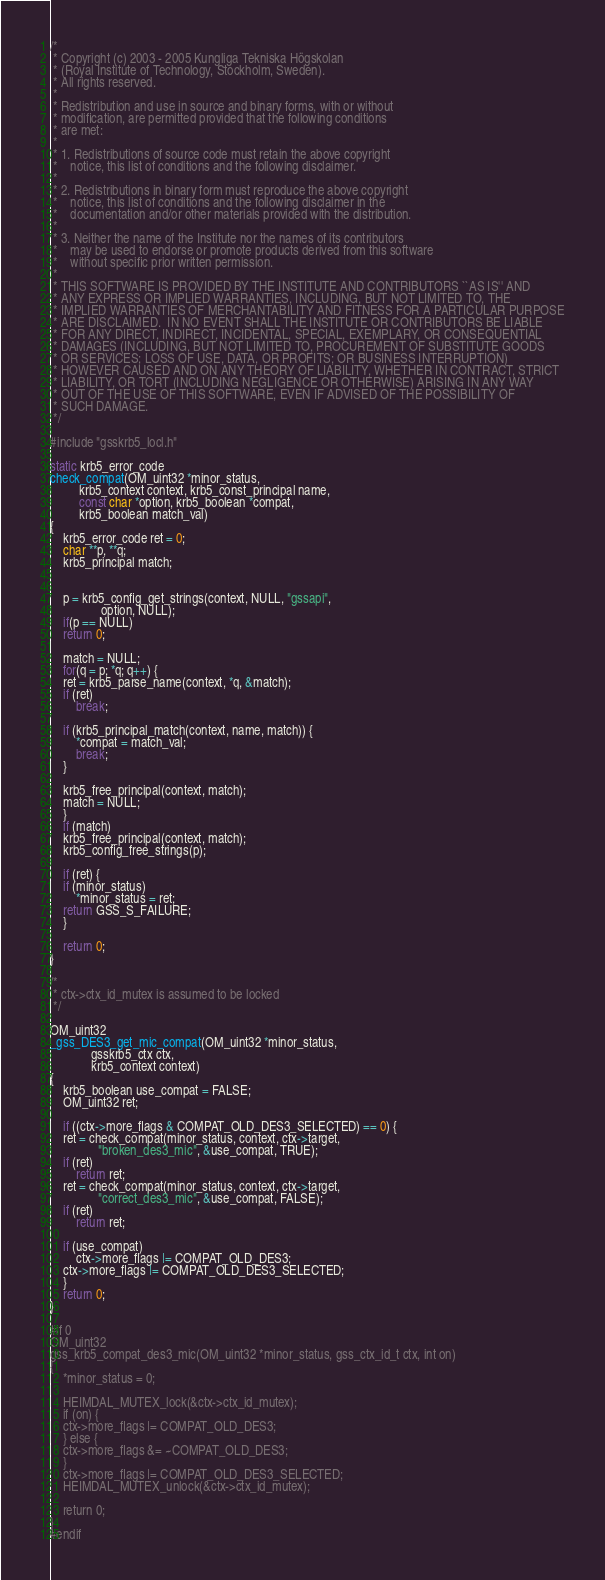Convert code to text. <code><loc_0><loc_0><loc_500><loc_500><_C_>/*
 * Copyright (c) 2003 - 2005 Kungliga Tekniska Högskolan
 * (Royal Institute of Technology, Stockholm, Sweden).
 * All rights reserved.
 *
 * Redistribution and use in source and binary forms, with or without
 * modification, are permitted provided that the following conditions
 * are met:
 *
 * 1. Redistributions of source code must retain the above copyright
 *    notice, this list of conditions and the following disclaimer.
 *
 * 2. Redistributions in binary form must reproduce the above copyright
 *    notice, this list of conditions and the following disclaimer in the
 *    documentation and/or other materials provided with the distribution.
 *
 * 3. Neither the name of the Institute nor the names of its contributors
 *    may be used to endorse or promote products derived from this software
 *    without specific prior written permission.
 *
 * THIS SOFTWARE IS PROVIDED BY THE INSTITUTE AND CONTRIBUTORS ``AS IS'' AND
 * ANY EXPRESS OR IMPLIED WARRANTIES, INCLUDING, BUT NOT LIMITED TO, THE
 * IMPLIED WARRANTIES OF MERCHANTABILITY AND FITNESS FOR A PARTICULAR PURPOSE
 * ARE DISCLAIMED.  IN NO EVENT SHALL THE INSTITUTE OR CONTRIBUTORS BE LIABLE
 * FOR ANY DIRECT, INDIRECT, INCIDENTAL, SPECIAL, EXEMPLARY, OR CONSEQUENTIAL
 * DAMAGES (INCLUDING, BUT NOT LIMITED TO, PROCUREMENT OF SUBSTITUTE GOODS
 * OR SERVICES; LOSS OF USE, DATA, OR PROFITS; OR BUSINESS INTERRUPTION)
 * HOWEVER CAUSED AND ON ANY THEORY OF LIABILITY, WHETHER IN CONTRACT, STRICT
 * LIABILITY, OR TORT (INCLUDING NEGLIGENCE OR OTHERWISE) ARISING IN ANY WAY
 * OUT OF THE USE OF THIS SOFTWARE, EVEN IF ADVISED OF THE POSSIBILITY OF
 * SUCH DAMAGE.
 */

#include "gsskrb5_locl.h"

static krb5_error_code
check_compat(OM_uint32 *minor_status,
	     krb5_context context, krb5_const_principal name,
	     const char *option, krb5_boolean *compat,
	     krb5_boolean match_val)
{
    krb5_error_code ret = 0;
    char **p, **q;
    krb5_principal match;


    p = krb5_config_get_strings(context, NULL, "gssapi",
				option, NULL);
    if(p == NULL)
	return 0;

    match = NULL;
    for(q = p; *q; q++) {
	ret = krb5_parse_name(context, *q, &match);
	if (ret)
	    break;

	if (krb5_principal_match(context, name, match)) {
	    *compat = match_val;
	    break;
	}

	krb5_free_principal(context, match);
	match = NULL;
    }
    if (match)
	krb5_free_principal(context, match);
    krb5_config_free_strings(p);

    if (ret) {
	if (minor_status)
	    *minor_status = ret;
	return GSS_S_FAILURE;
    }

    return 0;
}

/*
 * ctx->ctx_id_mutex is assumed to be locked
 */

OM_uint32
_gss_DES3_get_mic_compat(OM_uint32 *minor_status,
			 gsskrb5_ctx ctx,
			 krb5_context context)
{
    krb5_boolean use_compat = FALSE;
    OM_uint32 ret;

    if ((ctx->more_flags & COMPAT_OLD_DES3_SELECTED) == 0) {
	ret = check_compat(minor_status, context, ctx->target,
			   "broken_des3_mic", &use_compat, TRUE);
	if (ret)
	    return ret;
	ret = check_compat(minor_status, context, ctx->target,
			   "correct_des3_mic", &use_compat, FALSE);
	if (ret)
	    return ret;

	if (use_compat)
	    ctx->more_flags |= COMPAT_OLD_DES3;
	ctx->more_flags |= COMPAT_OLD_DES3_SELECTED;
    }
    return 0;
}

#if 0
OM_uint32
gss_krb5_compat_des3_mic(OM_uint32 *minor_status, gss_ctx_id_t ctx, int on)
{
    *minor_status = 0;

    HEIMDAL_MUTEX_lock(&ctx->ctx_id_mutex);
    if (on) {
	ctx->more_flags |= COMPAT_OLD_DES3;
    } else {
	ctx->more_flags &= ~COMPAT_OLD_DES3;
    }
    ctx->more_flags |= COMPAT_OLD_DES3_SELECTED;
    HEIMDAL_MUTEX_unlock(&ctx->ctx_id_mutex);

    return 0;
}
#endif
</code> 